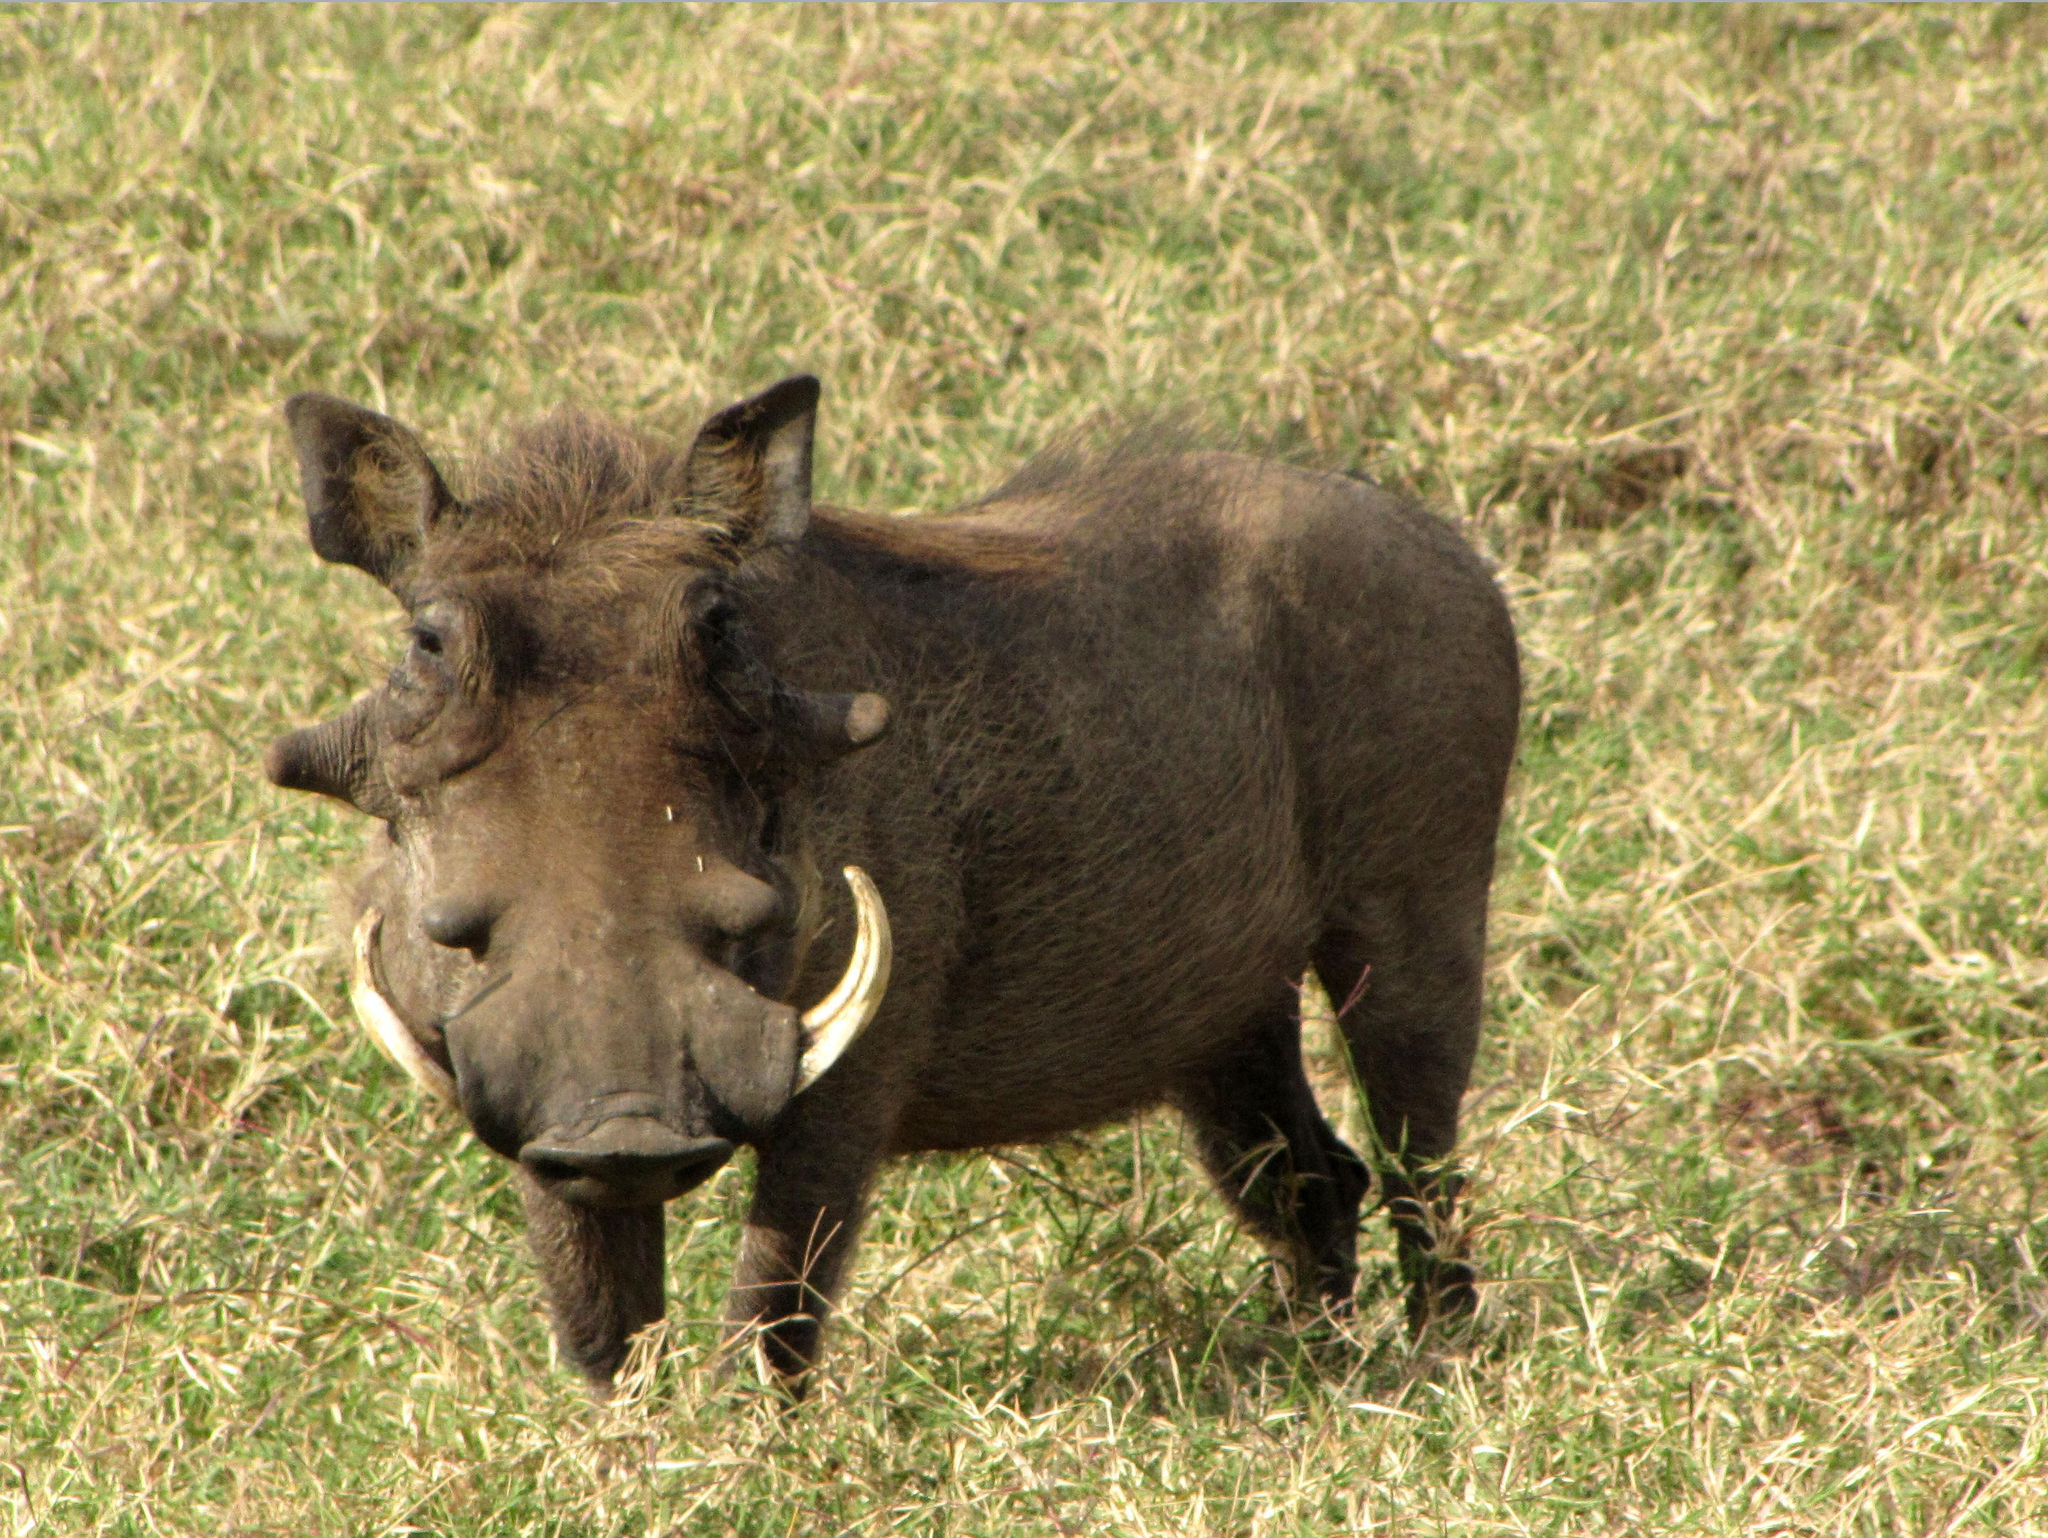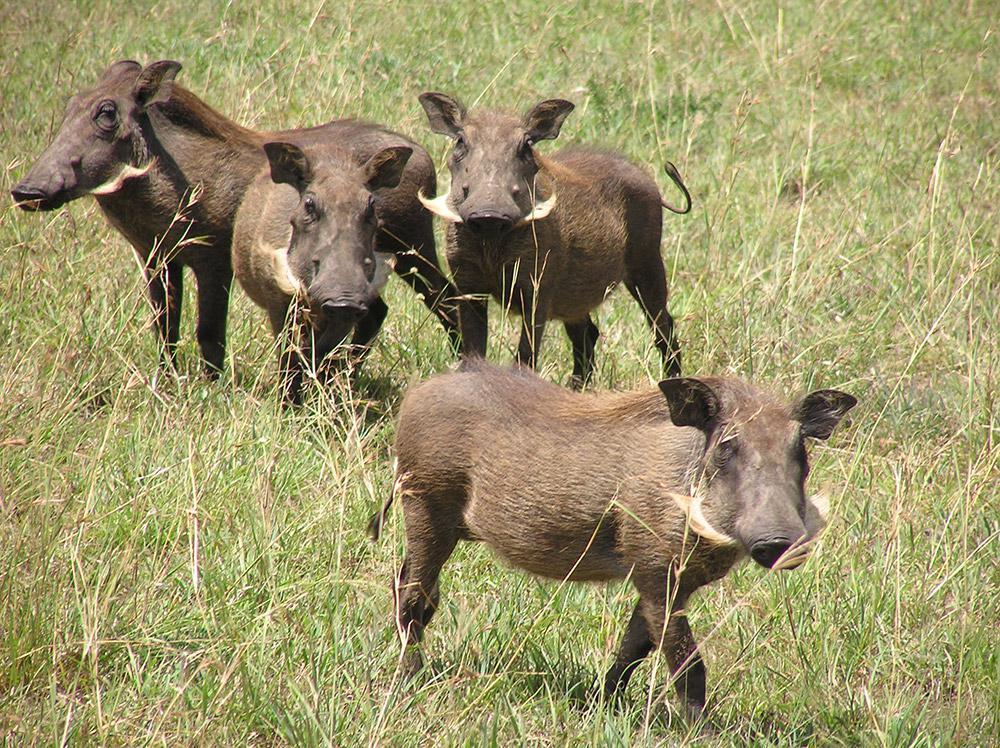The first image is the image on the left, the second image is the image on the right. For the images displayed, is the sentence "There are at least 4 hogs standing in grass." factually correct? Answer yes or no. Yes. The first image is the image on the left, the second image is the image on the right. For the images shown, is this caption "Left image shows one warthog with body in profile turned to the right." true? Answer yes or no. No. 